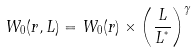Convert formula to latex. <formula><loc_0><loc_0><loc_500><loc_500>W _ { 0 } ( r , L ) = W _ { 0 } ( r ) \times \left ( \frac { L } { L ^ { ^ { * } } } \right ) ^ { \gamma }</formula> 